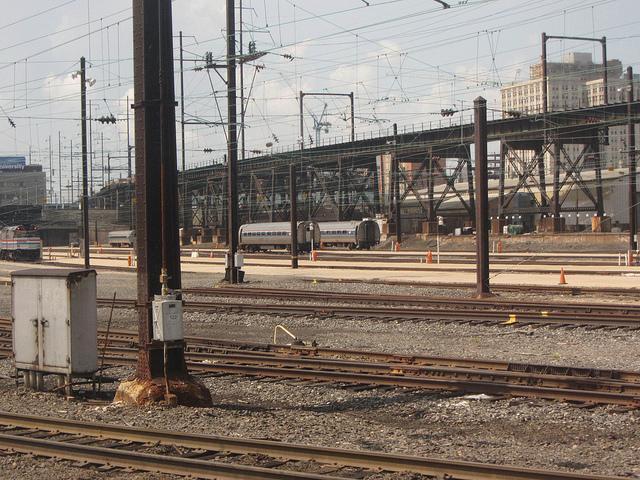How many of the women have stripes on their pants?
Give a very brief answer. 0. 